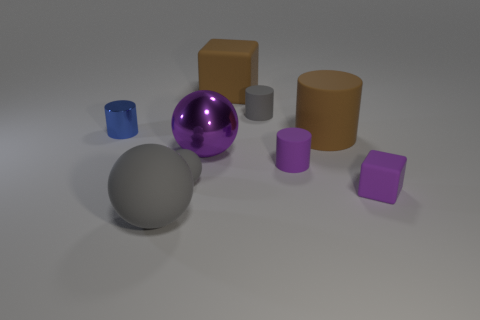There is another large matte thing that is the same shape as the blue thing; what is its color?
Keep it short and to the point. Brown. What number of tiny rubber objects have the same color as the large metal thing?
Offer a terse response. 2. What number of objects are either tiny gray rubber things behind the brown cylinder or blue objects?
Your answer should be very brief. 2. There is a gray matte ball that is behind the big gray ball; what size is it?
Provide a succinct answer. Small. Are there fewer purple things than large things?
Your response must be concise. Yes. Do the gray sphere behind the purple rubber cube and the brown thing in front of the blue cylinder have the same material?
Your answer should be very brief. Yes. The purple thing that is left of the gray rubber thing that is right of the big purple sphere on the left side of the large block is what shape?
Your answer should be compact. Sphere. How many tiny balls are the same material as the tiny purple cylinder?
Provide a succinct answer. 1. There is a brown thing that is on the right side of the tiny gray cylinder; what number of cylinders are in front of it?
Give a very brief answer. 1. There is a thing to the left of the large gray rubber thing; does it have the same color as the matte sphere that is behind the big gray rubber thing?
Your answer should be compact. No. 